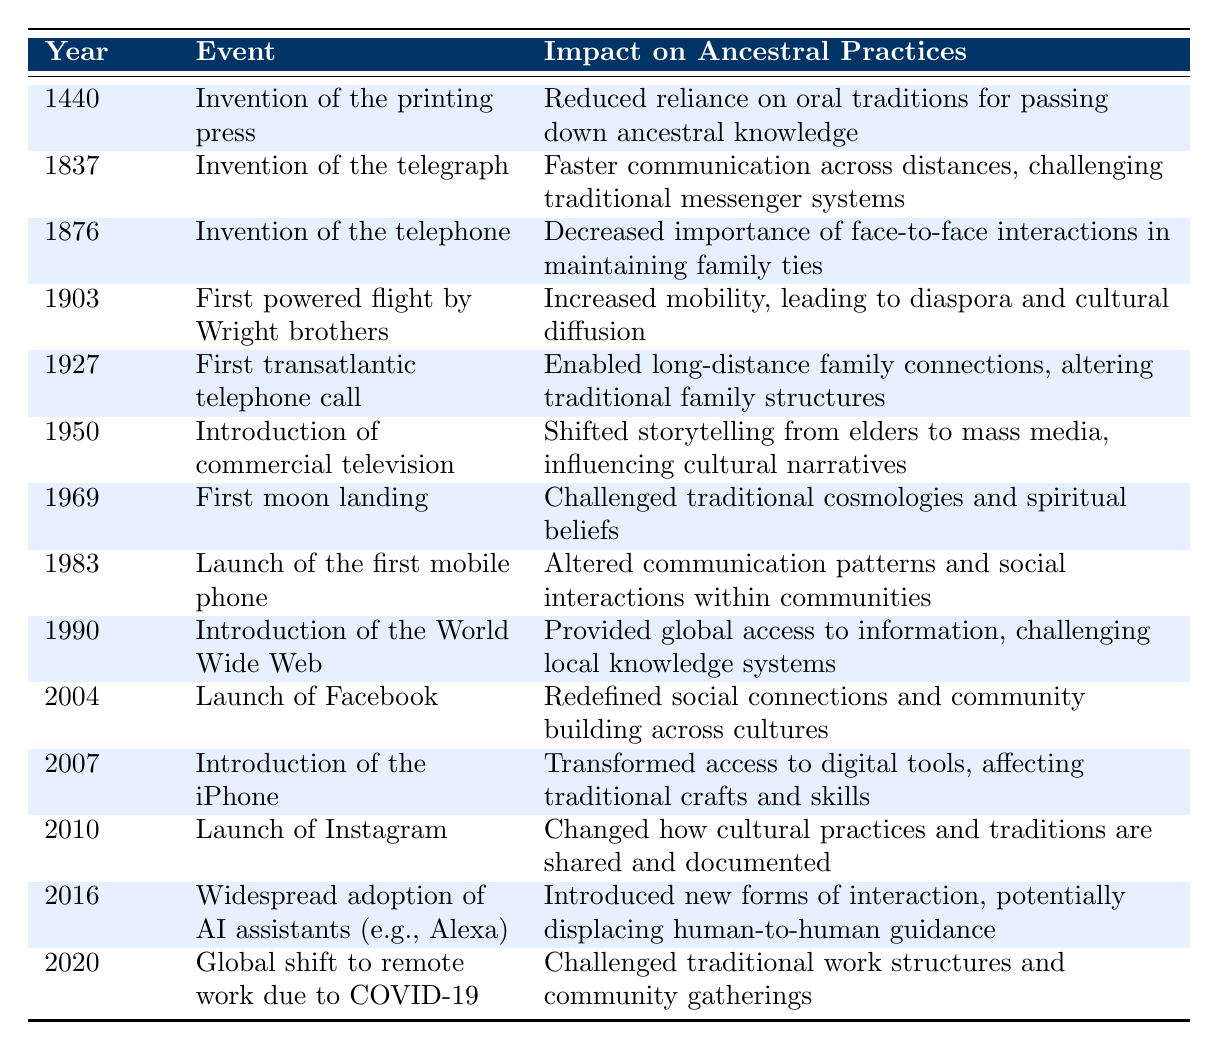What year was the invention of the printing press? The table lists the invention of the printing press in the year 1440.
Answer: 1440 What impact did the introduction of commercial television have on ancestral practices? According to the table, the introduction of commercial television in 1950 shifted storytelling from elders to mass media, influencing cultural narratives.
Answer: Shifted storytelling from elders to mass media Was there a significant increase in mobility after the first powered flight? The table indicates that the first powered flight by the Wright brothers in 1903 increased mobility, leading to diaspora and cultural diffusion.
Answer: Yes How many technological advancements listed occurred before 2000? By counting the events in the table that are dated before 2000, we find that there are 10 advancements (1440, 1837, 1876, 1903, 1927, 1950, 1969, 1983, 1990, and 2004).
Answer: 10 Which advancement led to challenges against local knowledge systems? The introduction of the World Wide Web in 1990 provided global access to information, which challenged local knowledge systems.
Answer: Introduction of the World Wide Web What was the impact of the first moon landing on traditional spiritual beliefs? The first moon landing in 1969 is noted to have challenged traditional cosmologies and spiritual beliefs according to the table.
Answer: Challenged traditional cosmologies and spiritual beliefs What is the difference in years between the invention of the telephone and the launch of Facebook? The invention of the telephone occurred in 1876 and the launch of Facebook occurred in 2004. The difference is 2004 - 1876 = 128 years.
Answer: 128 years Did the launch of Instagram have any effect on how cultural practices were shared? The table states that the launch of Instagram in 2010 changed how cultural practices and traditions are shared and documented, implying a yes to the question.
Answer: Yes What was the general trend of impacts from the technological advancements listed in relation to family ties? The impacts suggest a trend of decreasing importance of traditional face-to-face interactions amongst family members due to various technologies, such as the telephone and social media.
Answer: Decreasing importance of face-to-face interactions 